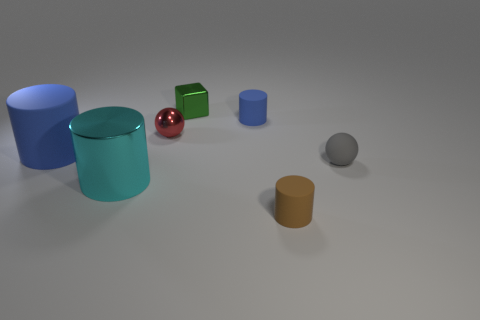Does the big rubber cylinder have the same color as the tiny rubber cylinder that is behind the tiny gray sphere?
Make the answer very short. Yes. How many other things are there of the same color as the shiny block?
Give a very brief answer. 0. Are there fewer tiny green objects than small gray metal objects?
Give a very brief answer. No. How many small metallic spheres are on the left side of the tiny sphere behind the sphere to the right of the small brown thing?
Offer a very short reply. 0. There is a matte object in front of the cyan metallic object; what size is it?
Ensure brevity in your answer.  Small. Is the shape of the rubber thing behind the red metal sphere the same as  the tiny red object?
Make the answer very short. No. There is a brown object that is the same shape as the large blue rubber object; what is it made of?
Offer a terse response. Rubber. Are there any big blue rubber things?
Your answer should be very brief. Yes. There is a large cylinder that is behind the sphere right of the small rubber object in front of the big shiny cylinder; what is it made of?
Ensure brevity in your answer.  Rubber. There is a large cyan metal object; is it the same shape as the blue object behind the small red thing?
Your response must be concise. Yes. 